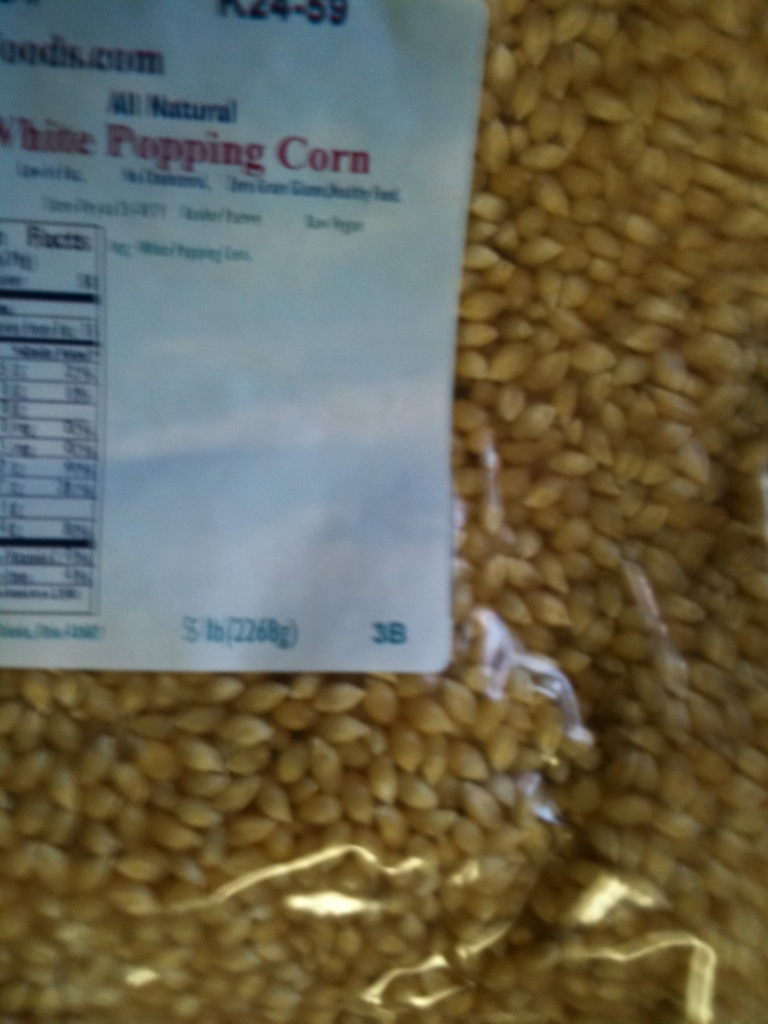What can you use this item for? This white popping corn can be used to make delicious homemade popcorn. You'll need a method to heat the corn, such as a stovetop pan, an air popper, or a microwave popcorn maker. Once popped, you can season it with butter, salt, or other flavors for a tasty snack. 